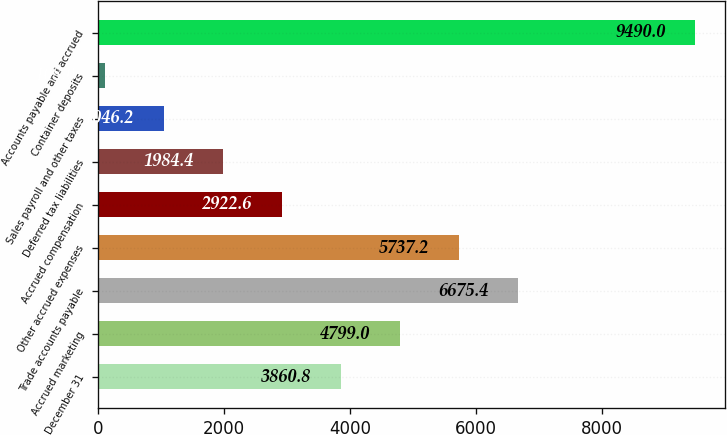Convert chart to OTSL. <chart><loc_0><loc_0><loc_500><loc_500><bar_chart><fcel>December 31<fcel>Accrued marketing<fcel>Trade accounts payable<fcel>Other accrued expenses<fcel>Accrued compensation<fcel>Deferred tax liabilities<fcel>Sales payroll and other taxes<fcel>Container deposits<fcel>Accounts payable and accrued<nl><fcel>3860.8<fcel>4799<fcel>6675.4<fcel>5737.2<fcel>2922.6<fcel>1984.4<fcel>1046.2<fcel>108<fcel>9490<nl></chart> 